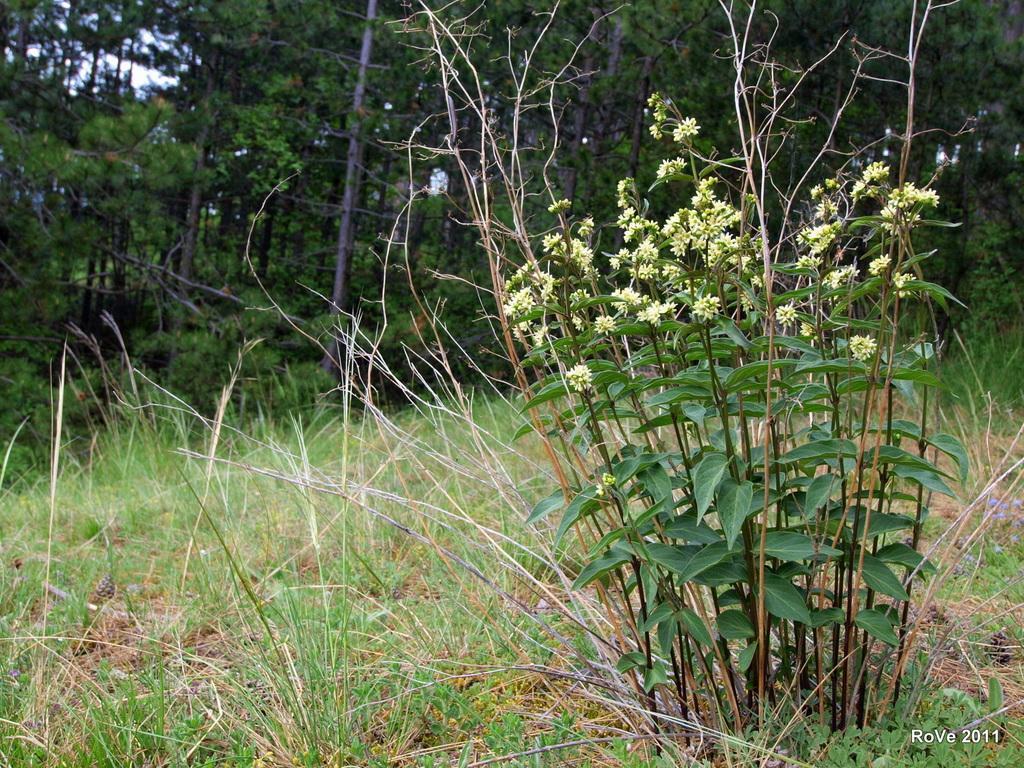Describe this image in one or two sentences. On the right we can see plants with small flowers. At the bottom we can see grass on the ground. In the background there are trees and sky. 